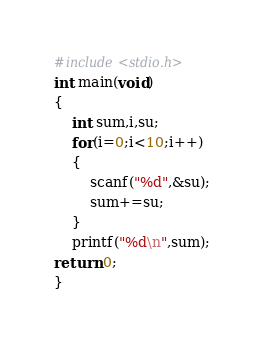Convert code to text. <code><loc_0><loc_0><loc_500><loc_500><_C_>#include<stdio.h>
int main(void)
{
	int sum,i,su;
	for(i=0;i<10;i++)
	{
		scanf("%d",&su);
		sum+=su;
	}
	printf("%d\n",sum);
return 0;
}</code> 